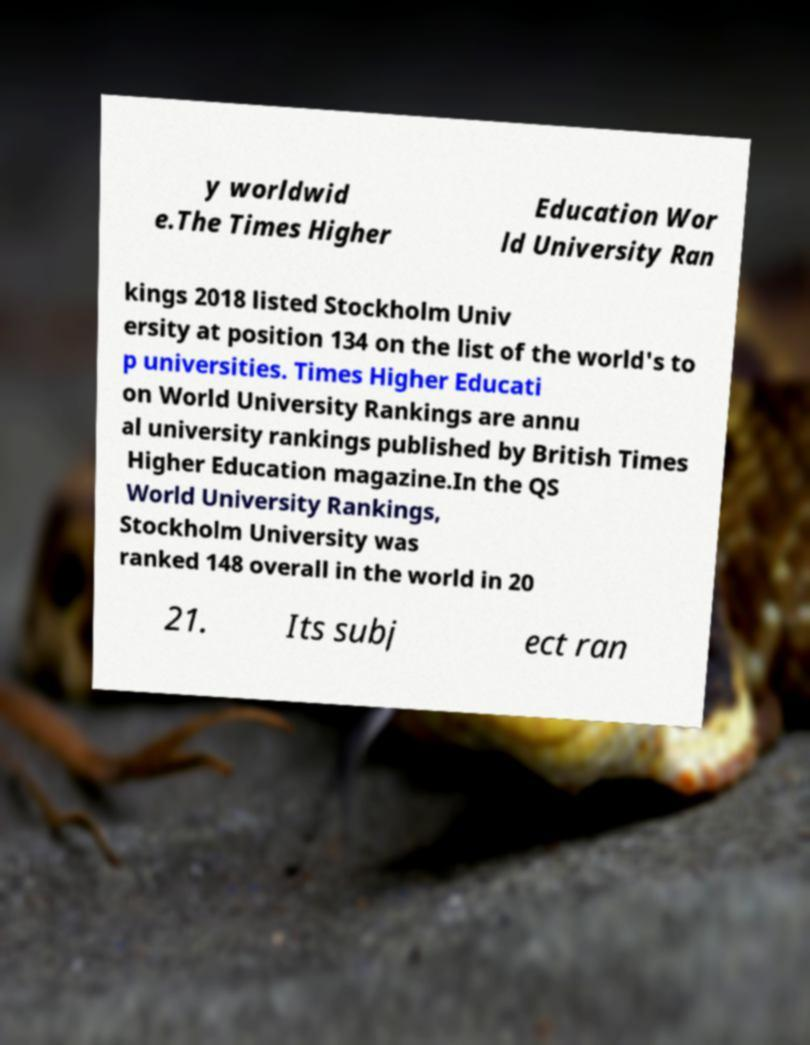Please identify and transcribe the text found in this image. y worldwid e.The Times Higher Education Wor ld University Ran kings 2018 listed Stockholm Univ ersity at position 134 on the list of the world's to p universities. Times Higher Educati on World University Rankings are annu al university rankings published by British Times Higher Education magazine.In the QS World University Rankings, Stockholm University was ranked 148 overall in the world in 20 21. Its subj ect ran 